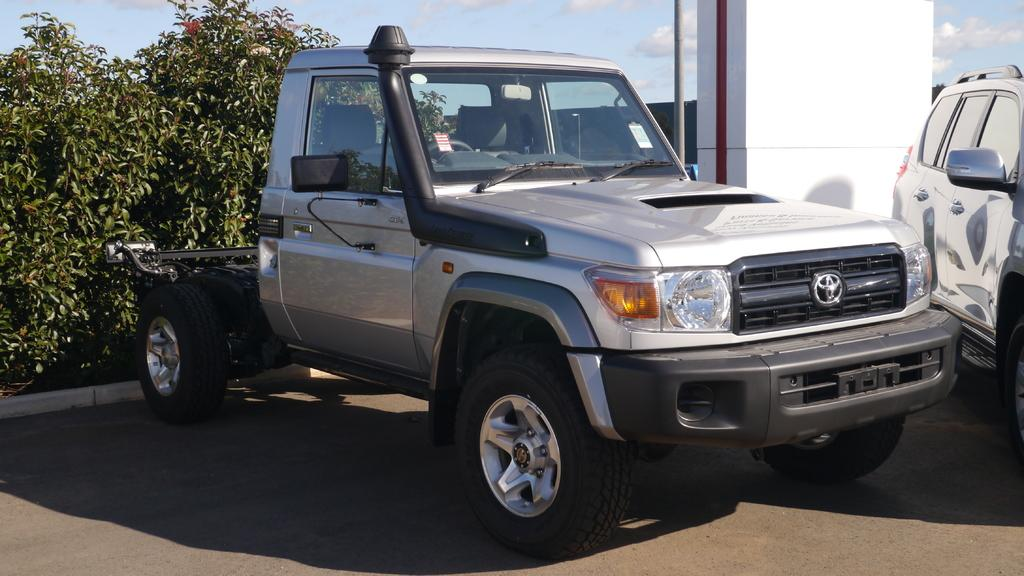What is the main subject of the image? There is a car in the image. Where is the car located? The car is placed on the road. What else can be seen in the image besides the car? There are plants, a pillar, and a pole in the image. What is visible in the background of the image? The sky is visible in the image, and it appears to be cloudy. Can you tell me how many friends are playing baseball in the image? There are no friends or baseball game present in the image. What type of kettle is visible in the image? There is no kettle present in the image. 